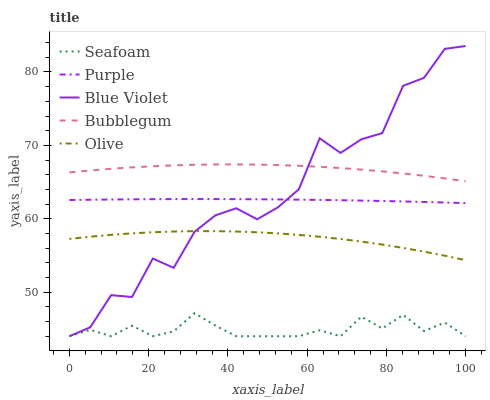Does Seafoam have the minimum area under the curve?
Answer yes or no. Yes. Does Bubblegum have the maximum area under the curve?
Answer yes or no. Yes. Does Olive have the minimum area under the curve?
Answer yes or no. No. Does Olive have the maximum area under the curve?
Answer yes or no. No. Is Purple the smoothest?
Answer yes or no. Yes. Is Blue Violet the roughest?
Answer yes or no. Yes. Is Olive the smoothest?
Answer yes or no. No. Is Olive the roughest?
Answer yes or no. No. Does Seafoam have the lowest value?
Answer yes or no. Yes. Does Olive have the lowest value?
Answer yes or no. No. Does Blue Violet have the highest value?
Answer yes or no. Yes. Does Olive have the highest value?
Answer yes or no. No. Is Seafoam less than Bubblegum?
Answer yes or no. Yes. Is Purple greater than Seafoam?
Answer yes or no. Yes. Does Blue Violet intersect Seafoam?
Answer yes or no. Yes. Is Blue Violet less than Seafoam?
Answer yes or no. No. Is Blue Violet greater than Seafoam?
Answer yes or no. No. Does Seafoam intersect Bubblegum?
Answer yes or no. No. 